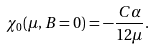<formula> <loc_0><loc_0><loc_500><loc_500>\chi _ { 0 } ( \mu , B = 0 ) = - \frac { C \alpha } { 1 2 \mu } .</formula> 